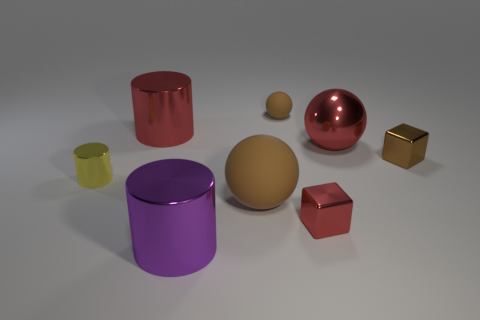What is the material of the small brown object that is the same shape as the small red metallic object?
Offer a very short reply. Metal. What number of big objects are shiny things or green metallic cylinders?
Keep it short and to the point. 3. Are there fewer tiny balls that are left of the brown cube than brown things right of the big brown object?
Make the answer very short. Yes. How many things are rubber blocks or shiny things?
Your response must be concise. 6. There is a small yellow metallic thing; how many big objects are behind it?
Offer a terse response. 2. Is the tiny shiny cylinder the same color as the large shiny sphere?
Your answer should be compact. No. What shape is the brown object that is made of the same material as the red cube?
Your response must be concise. Cube. Is the shape of the small shiny thing to the left of the red metallic cube the same as  the big rubber object?
Provide a short and direct response. No. How many brown things are either shiny things or large matte spheres?
Your answer should be very brief. 2. Are there an equal number of brown blocks that are on the left side of the large purple object and small cylinders behind the large rubber thing?
Your answer should be very brief. No. 